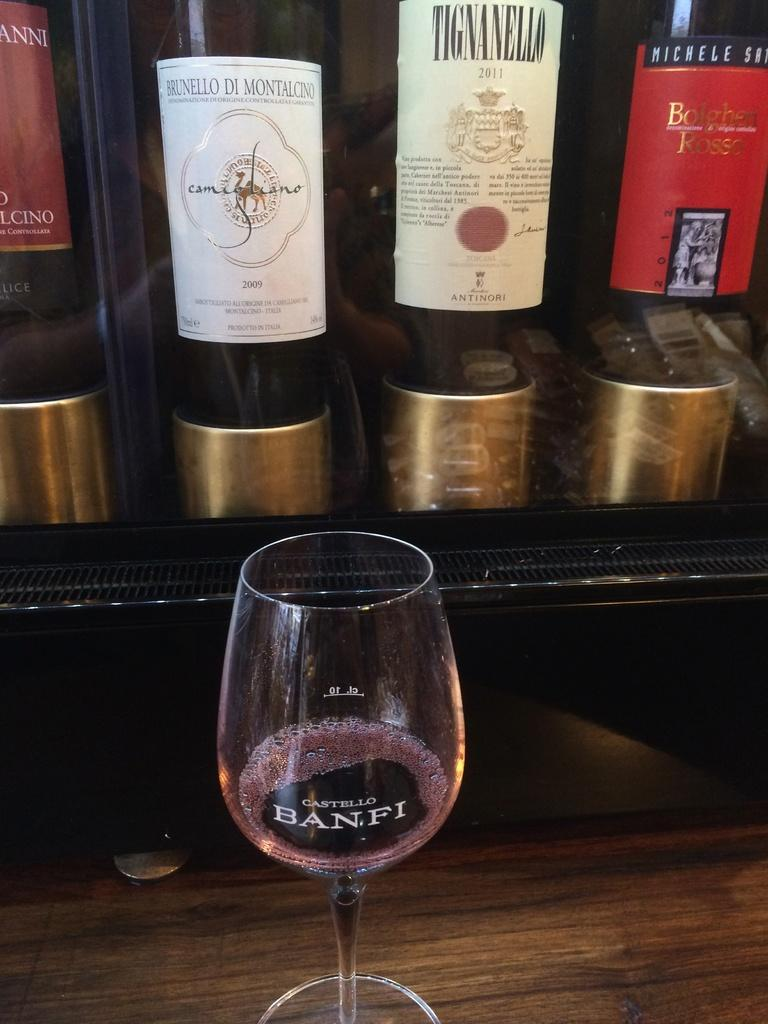<image>
Relay a brief, clear account of the picture shown. "BANFI" is on the front of the wine glass. 